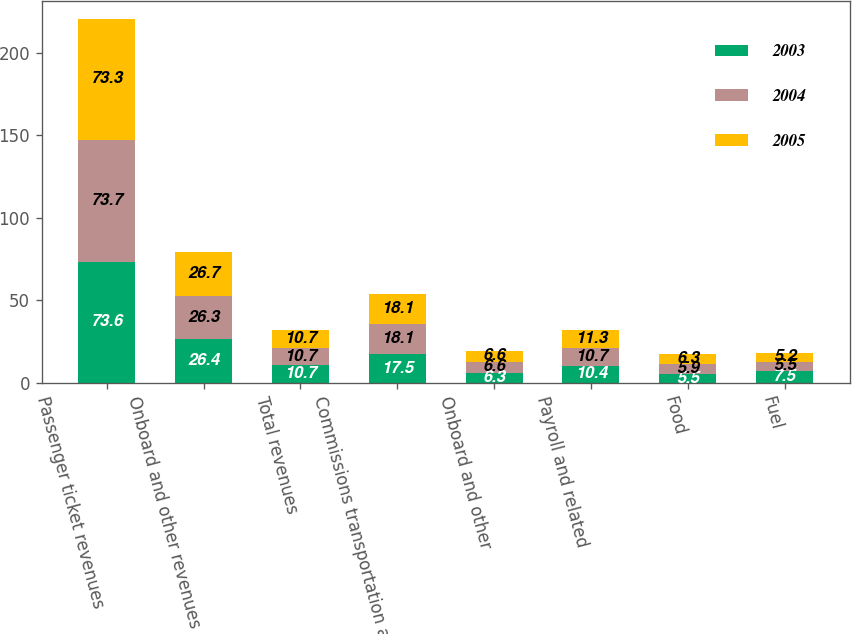<chart> <loc_0><loc_0><loc_500><loc_500><stacked_bar_chart><ecel><fcel>Passenger ticket revenues<fcel>Onboard and other revenues<fcel>Total revenues<fcel>Commissions transportation and<fcel>Onboard and other<fcel>Payroll and related<fcel>Food<fcel>Fuel<nl><fcel>2003<fcel>73.6<fcel>26.4<fcel>10.7<fcel>17.5<fcel>6.3<fcel>10.4<fcel>5.5<fcel>7.5<nl><fcel>2004<fcel>73.7<fcel>26.3<fcel>10.7<fcel>18.1<fcel>6.6<fcel>10.7<fcel>5.9<fcel>5.5<nl><fcel>2005<fcel>73.3<fcel>26.7<fcel>10.7<fcel>18.1<fcel>6.6<fcel>11.3<fcel>6.3<fcel>5.2<nl></chart> 